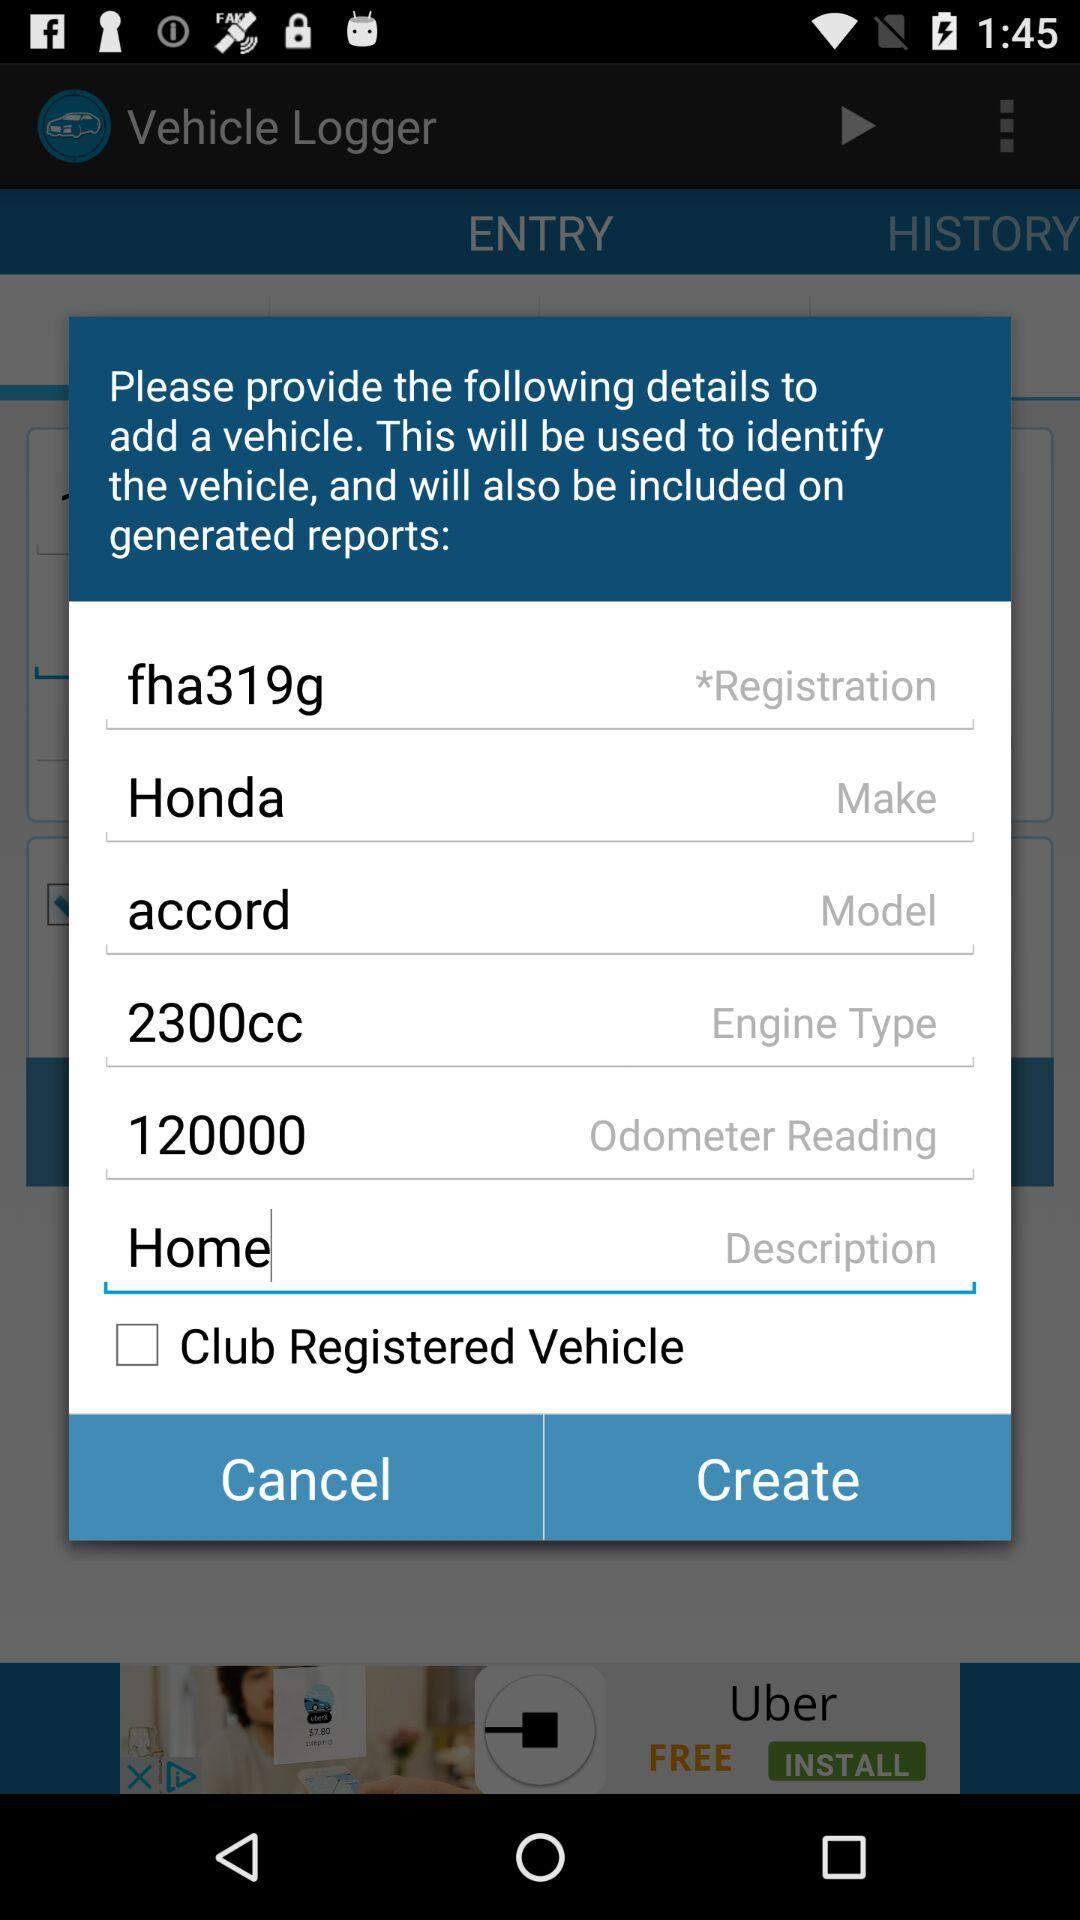What is the engine type? The engine type is 2300cc. 